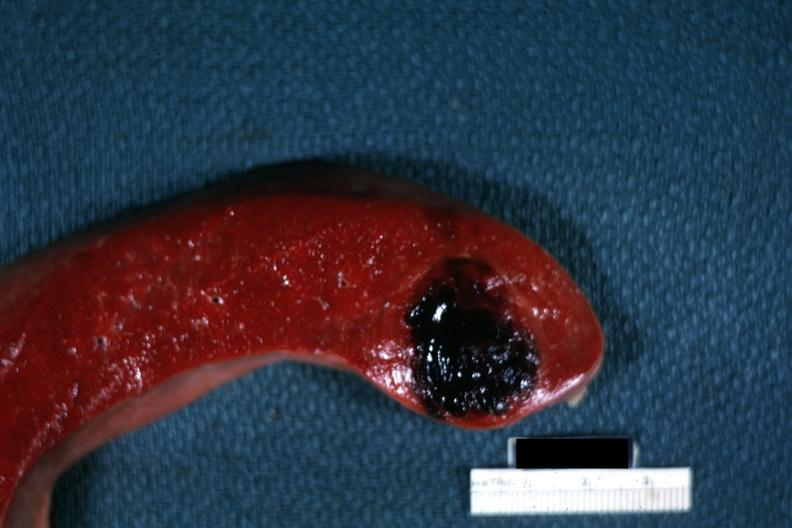s fibrous meningioma present?
Answer the question using a single word or phrase. No 